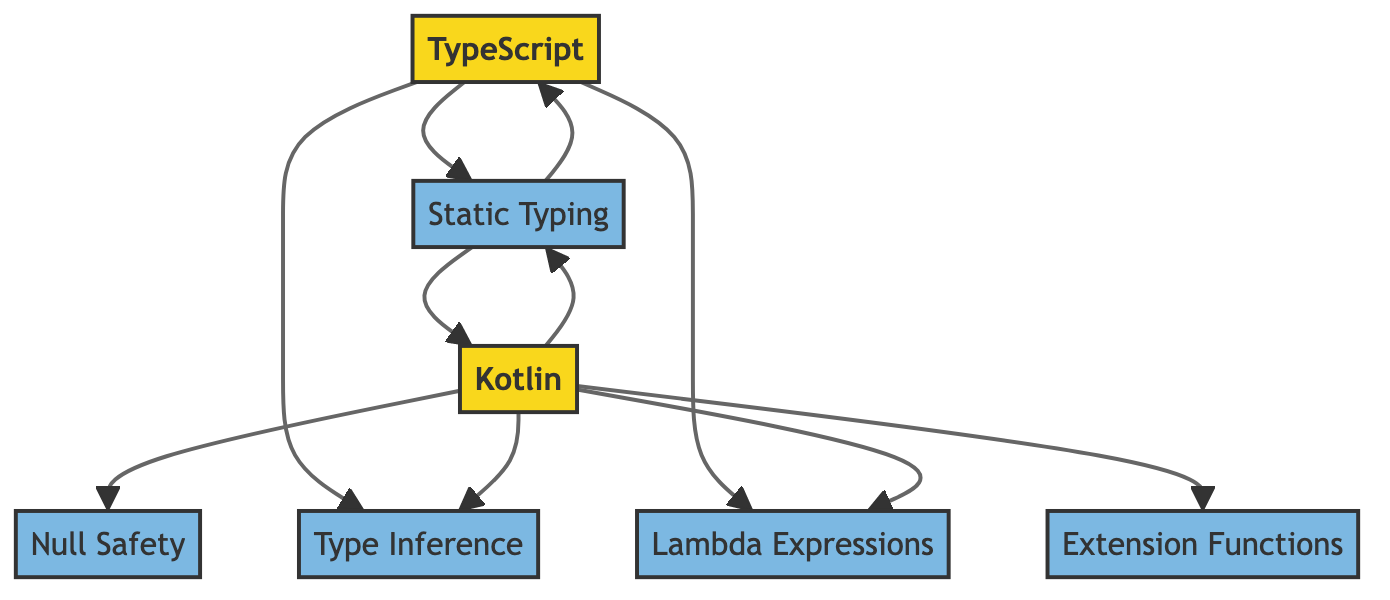What are the languages represented in the diagram? The diagram has two nodes labeled as "TypeScript" and "Kotlin," which indicate the languages being compared.
Answer: TypeScript, Kotlin How many features are associated with Kotlin? By examining the outgoing edges from the "Kotlin" node, there are five edges pointing to different features: "Static Typing," "Null Safety," "Type Inference," "Lambda Expressions," and "Extension Functions." This shows that Kotlin has five associated features.
Answer: 5 Which feature is unique to Kotlin and not present for TypeScript? By checking the outgoing edges, the "Kotlin" node has an edge pointing to "Null Safety," which is absent in the outgoing edges from the "TypeScript" node. Thus, "Null Safety" is the unique feature.
Answer: Null Safety What is the relationship between TypeScript and Static Typing? The diagram shows a directed edge from the "TypeScript" node to the "Static Typing" node, indicating that TypeScript is associated with static typing. This establishes a direct relationship where TypeScript utilizes static typing.
Answer: TypeScript has Static Typing Which feature do both TypeScript and Kotlin share? The edges from both "TypeScript" and "Kotlin" lead to "Static Typing," "Type Inference," and "Lambda Expressions." Therefore, these are features shared by both languages. Selecting one, "Static Typing" represents a shared feature.
Answer: Static Typing How many total features are represented in the diagram? Counting the unique feature nodes: "Static Typing," "Null Safety," "Type Inference," "Lambda Expressions," and "Extension Functions," gives a total of five unique features in the diagram.
Answer: 5 Which node has the most incoming edges? The "Static Typing" node has two incoming edges, one from the "TypeScript" node and another from the "Kotlin" node, which shows it is the most referenced feature by the language nodes.
Answer: Static Typing What type of graph is represented in the diagram? The directed edges indicate a flow from the languages to their associated features and also from features back to the languages, affirming that it is a directed graph.
Answer: Directed Graph 